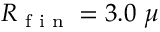<formula> <loc_0><loc_0><loc_500><loc_500>R \text  subscript { f i n } = 3 . 0 \mu</formula> 